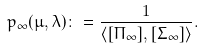<formula> <loc_0><loc_0><loc_500><loc_500>p _ { \infty } ( \mu , \lambda ) \colon = \frac { 1 } { \langle [ \Pi _ { \infty } ] , [ \Sigma _ { \infty } ] \rangle } .</formula> 